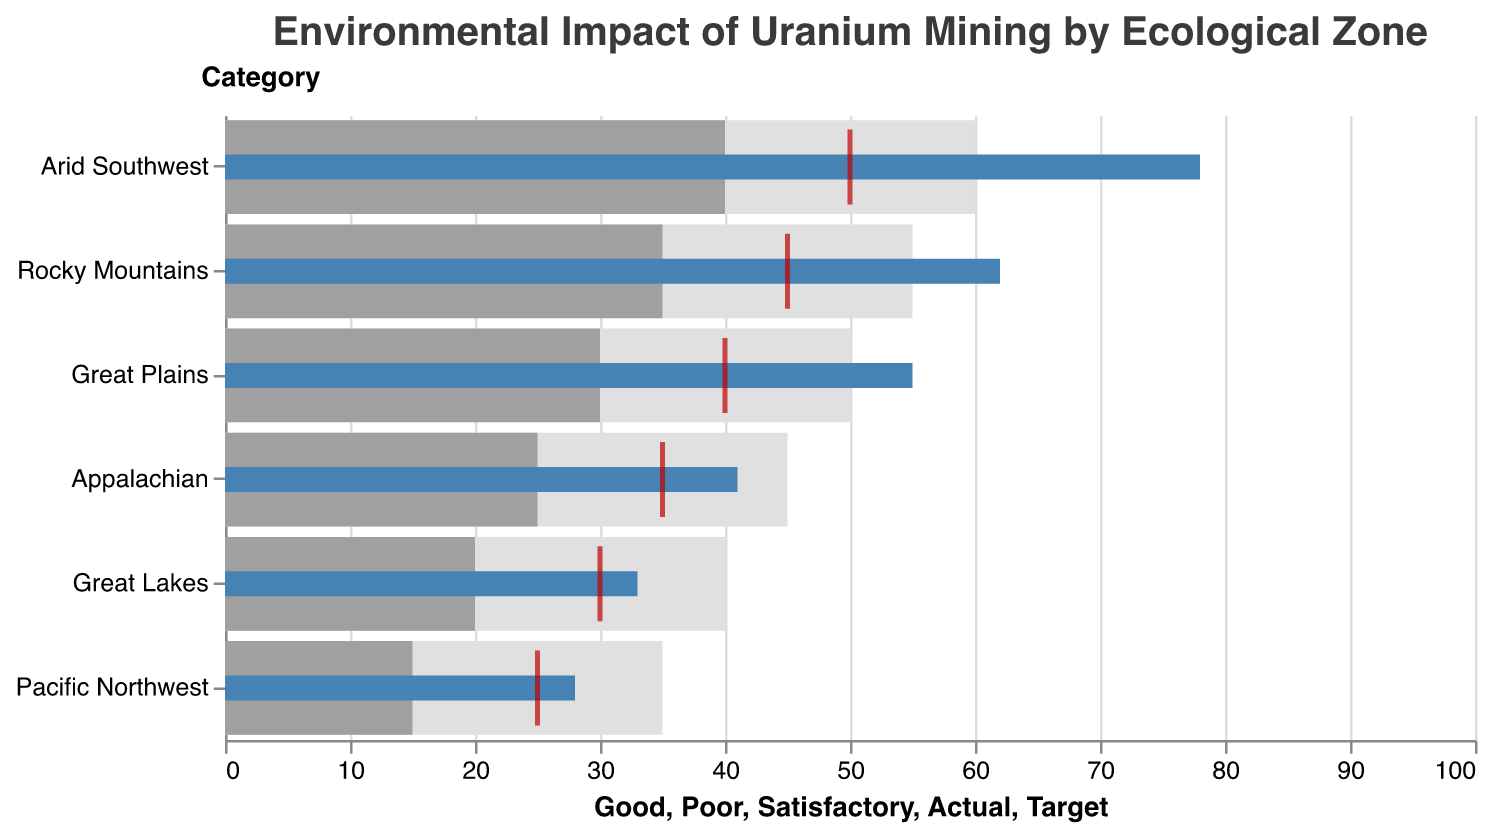What's the ecological zone with the highest actual environmental impact from uranium mining? The actual environmental impact is represented by blue bars, and the Arid Southwest has the highest actual value of 78.
Answer: Arid Southwest How does the actual impact in the Great Plains compare with its target? The Great Plains has an actual impact of 55 and a target of 40, so the actual impact is 15 units higher than the target.
Answer: 15 units higher What zone has the smallest gap between actual and target impact levels? Comparing the gaps between actual (blue bars) and target (red tick marks) for all zones, the Great Lakes has the actual at 33 and the target at 30, resulting in a gap of 3, which is the smallest.
Answer: Great Lakes Which zones have an actual environmental impact higher than their Good standard? The zones where the blue bars exceed the highest brown shaded region (representing Good) are the Arid Southwest, Rocky Mountains, and Great Plains.
Answer: Arid Southwest, Rocky Mountains, Great Plains What's the average target environmental impact across all ecological zones? Adding the target impacts for all zones together: 50 (Arid Southwest) + 45 (Rocky Mountains) + 40 (Great Plains) + 35 (Appalachian) + 30 (Great Lakes) + 25 (Pacific Northwest) = 225. Then, divide by the number of zones, 225 / 6 = 37.5.
Answer: 37.5 In what zone does the actual impact fall within the Poor range? According to the gray and lighter gray shades representing Poor and Satisfactory, the Pacific Northwest's actual impact (28) falls within this range.
Answer: Pacific Northwest Which zone has the largest difference between its Satisfactory and Good standards? Comparing the differences between the tan and brown sections for each zone, the Arid Southwest (60-40=20) has the largest difference.
Answer: Arid Southwest How many zones have an actual impact that exceeds the Satisfactory standard but not the Good standard? The actual blue bars for Great Plains, Appalachian, and Great Lakes exceed the Satisfactory but not the Good.
Answer: Three zones What's the total actual environmental impact across all zones? Summing the actual impacts: 78 (Arid Southwest) + 62 (Rocky Mountains) + 55 (Great Plains) + 41 (Appalachian) + 33 (Great Lakes) + 28 (Pacific Northwest) = 297.
Answer: 297 How does the impact in the Pacific Northwest compare with the Appalachian? The actual impact in the Pacific Northwest is 28, while in the Appalachian it is 41. Thus, the Appalachian has a higher impact by 13 units.
Answer: 13 units higher in Appalachian 